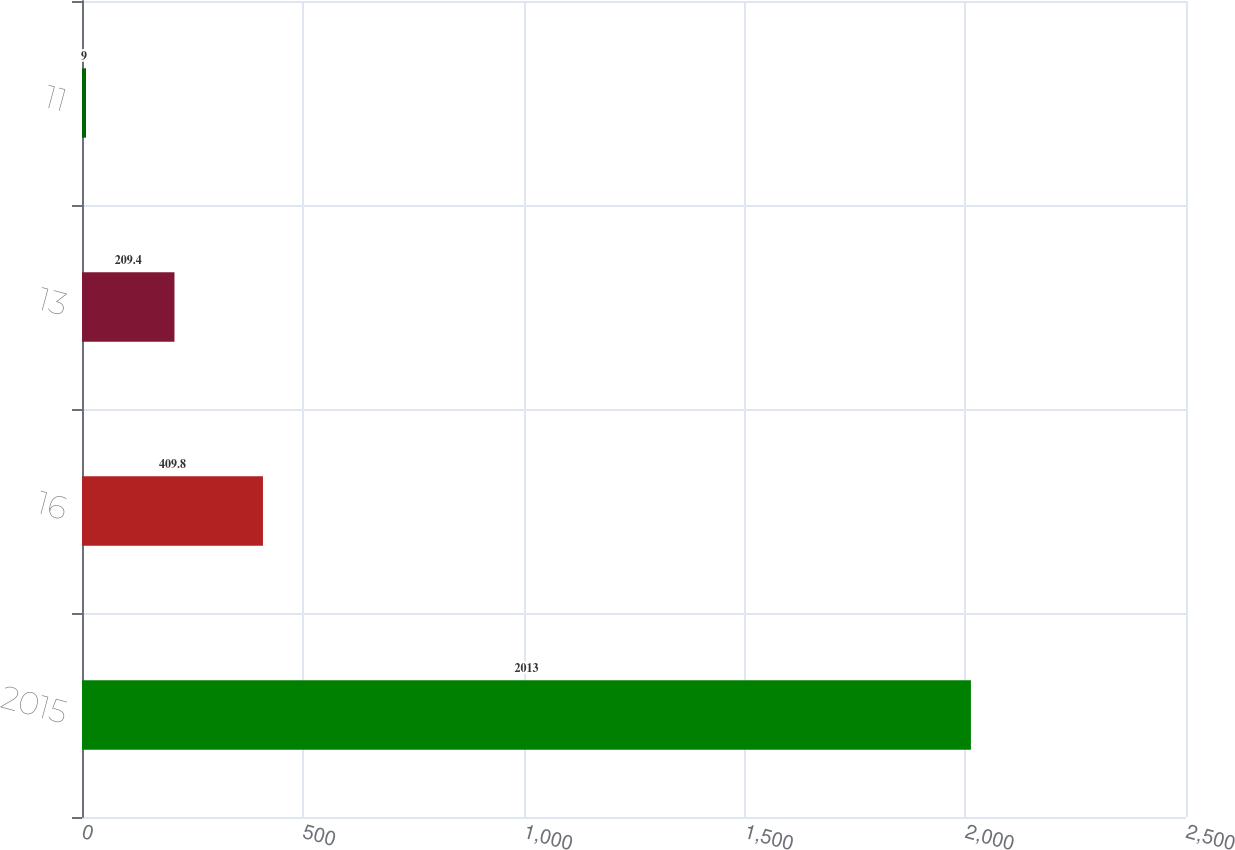<chart> <loc_0><loc_0><loc_500><loc_500><bar_chart><fcel>2015<fcel>16<fcel>13<fcel>11<nl><fcel>2013<fcel>409.8<fcel>209.4<fcel>9<nl></chart> 